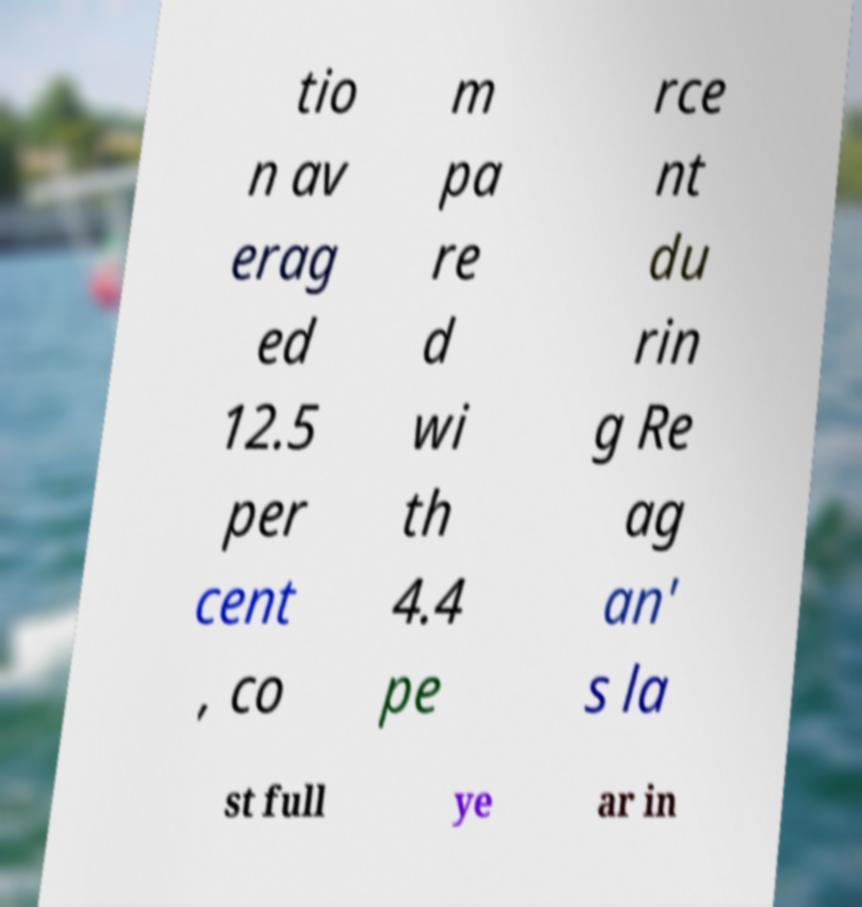There's text embedded in this image that I need extracted. Can you transcribe it verbatim? tio n av erag ed 12.5 per cent , co m pa re d wi th 4.4 pe rce nt du rin g Re ag an' s la st full ye ar in 